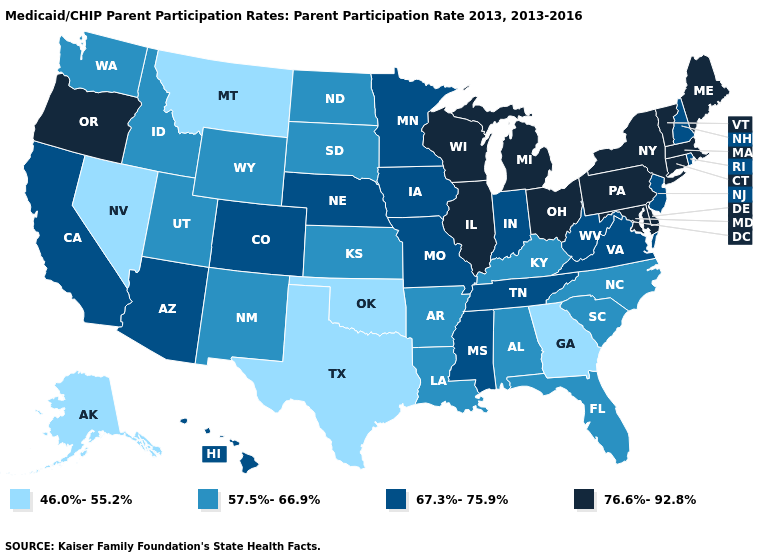What is the lowest value in the MidWest?
Answer briefly. 57.5%-66.9%. Does Montana have the lowest value in the West?
Short answer required. Yes. Name the states that have a value in the range 67.3%-75.9%?
Quick response, please. Arizona, California, Colorado, Hawaii, Indiana, Iowa, Minnesota, Mississippi, Missouri, Nebraska, New Hampshire, New Jersey, Rhode Island, Tennessee, Virginia, West Virginia. Is the legend a continuous bar?
Write a very short answer. No. What is the value of Maine?
Answer briefly. 76.6%-92.8%. Among the states that border Florida , does Georgia have the highest value?
Keep it brief. No. What is the value of Hawaii?
Keep it brief. 67.3%-75.9%. What is the value of Arizona?
Concise answer only. 67.3%-75.9%. What is the value of South Carolina?
Keep it brief. 57.5%-66.9%. Does Pennsylvania have the lowest value in the USA?
Short answer required. No. Which states hav the highest value in the South?
Quick response, please. Delaware, Maryland. Does Nevada have the lowest value in the West?
Keep it brief. Yes. How many symbols are there in the legend?
Write a very short answer. 4. How many symbols are there in the legend?
Write a very short answer. 4. 